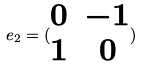<formula> <loc_0><loc_0><loc_500><loc_500>e _ { 2 } = ( \begin{matrix} 0 & - 1 \\ 1 & 0 \end{matrix} )</formula> 